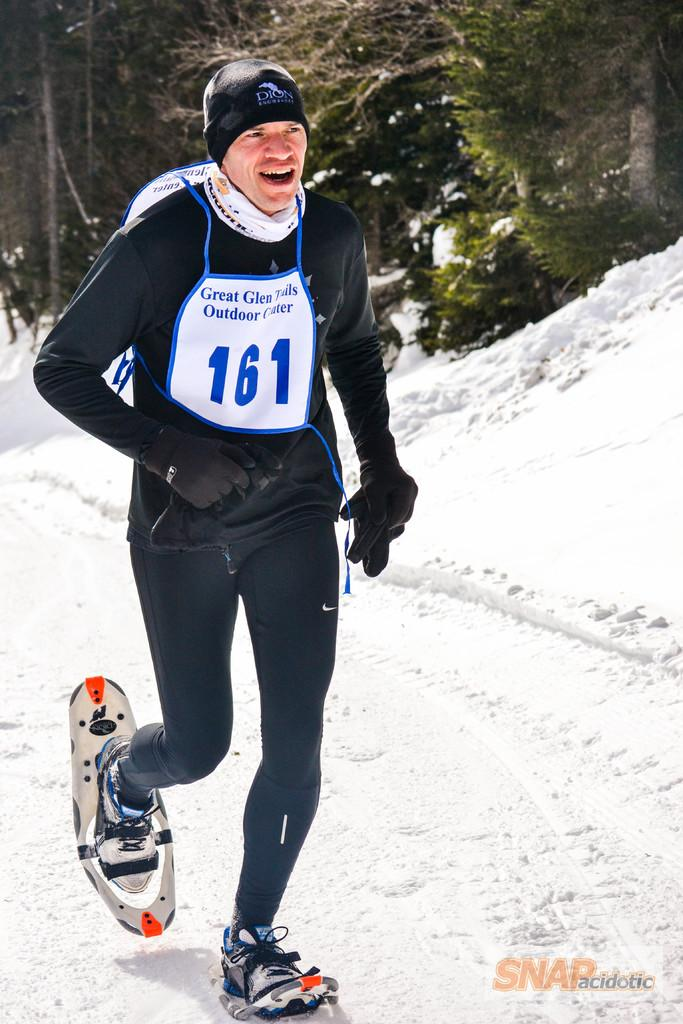What is the person in the image doing? The person is running in the image. What type of terrain is the person running on? The person is running on snow. What can be seen in the background of the image? There are trees in the background of the image. Is there any text present in the image? Yes, there is some text on the right side of the image. What type of stove is visible in the image? There is no stove present in the image. How does the calculator help the achiever in the image? There is no calculator or achiever present in the image. 